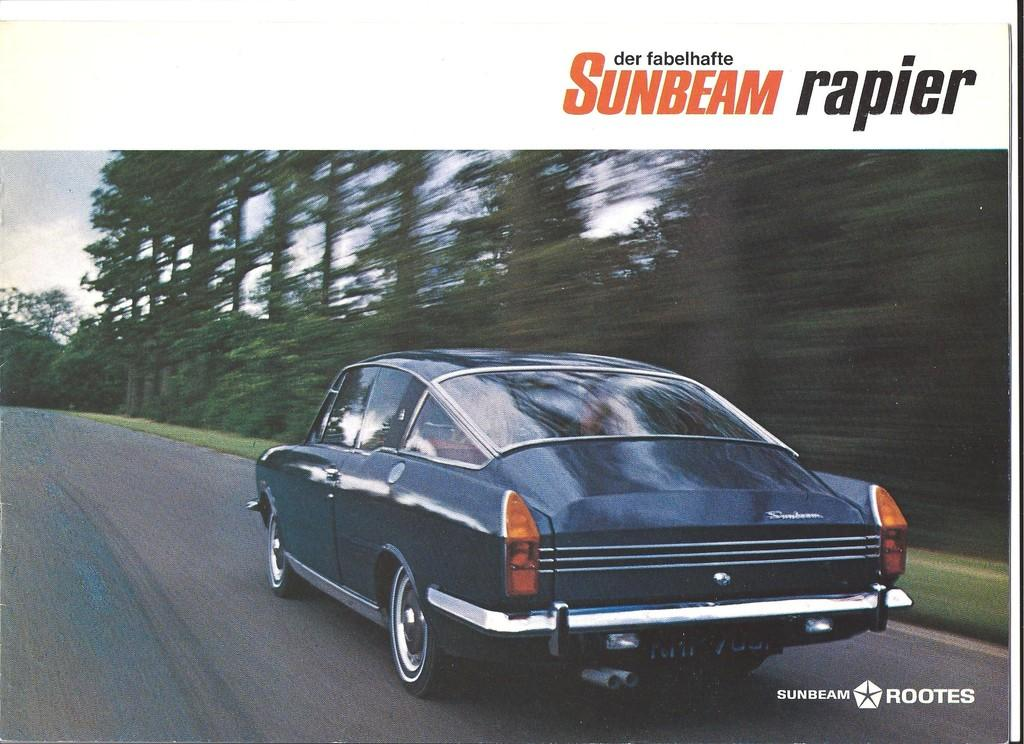What is the main subject of the image? The main subject of the image is a car. What is the car doing in the image? The car is moving fast in the image. Where is the car located in the image? The car is on the road in the image. What can be seen in the background of the image? There are trees in the background of the image. What is visible at the top of the image? The sky is visible at the top of the image. What type of authority figure can be seen in the image? There is no authority figure present in the image; it features a car moving fast on the road. Can you tell me how many cobwebs are visible in the image? There are no cobwebs present in the image. 